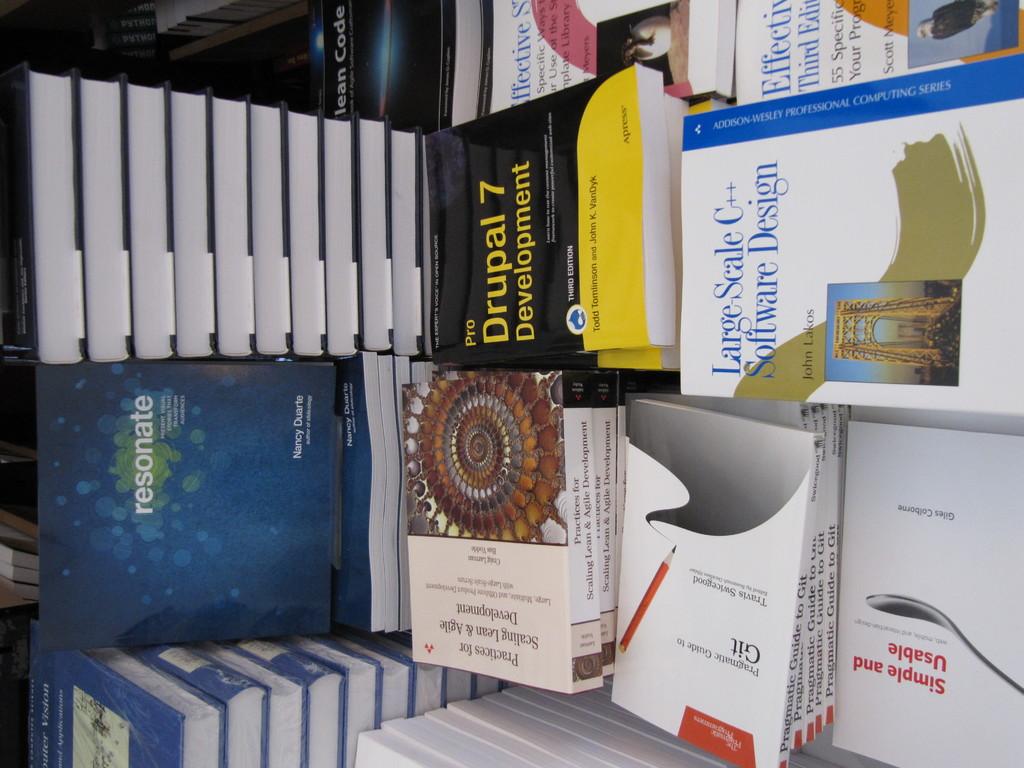Which version of code does the software book teach?
Provide a succinct answer. C++. What is the title of the book in yellow?
Your response must be concise. Drupal 7 development. 